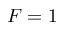Convert formula to latex. <formula><loc_0><loc_0><loc_500><loc_500>F = 1</formula> 